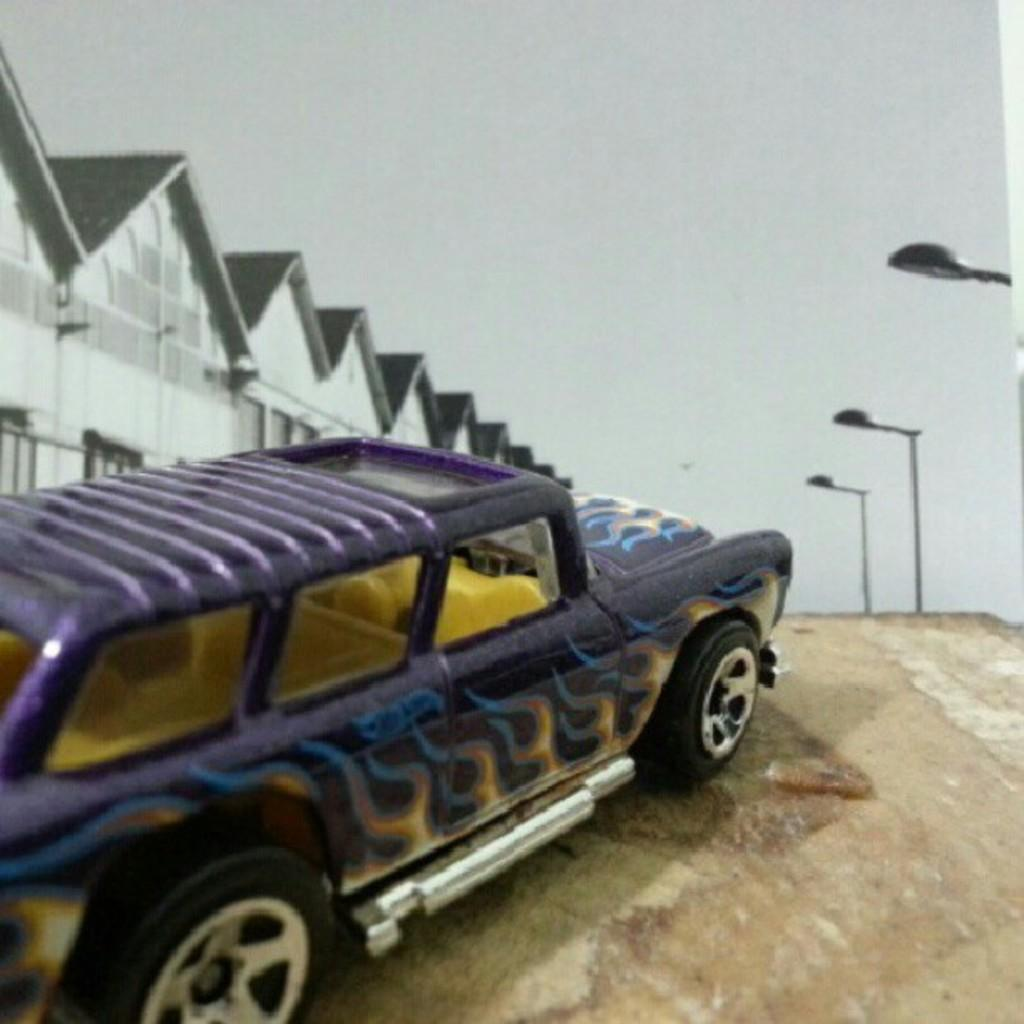What is the main subject of the image? There is a car in the image. What colors are used to paint the car? The car is violet and yellow in color. Where is the car located in the image? The car is on the ground. What can be seen in the background of the image? There are buildings, street light poles, and the sky visible in the background of the image. Is there a toothbrush being used to clean the car in the image? There is no toothbrush present in the image, and no cleaning activity is depicted. 